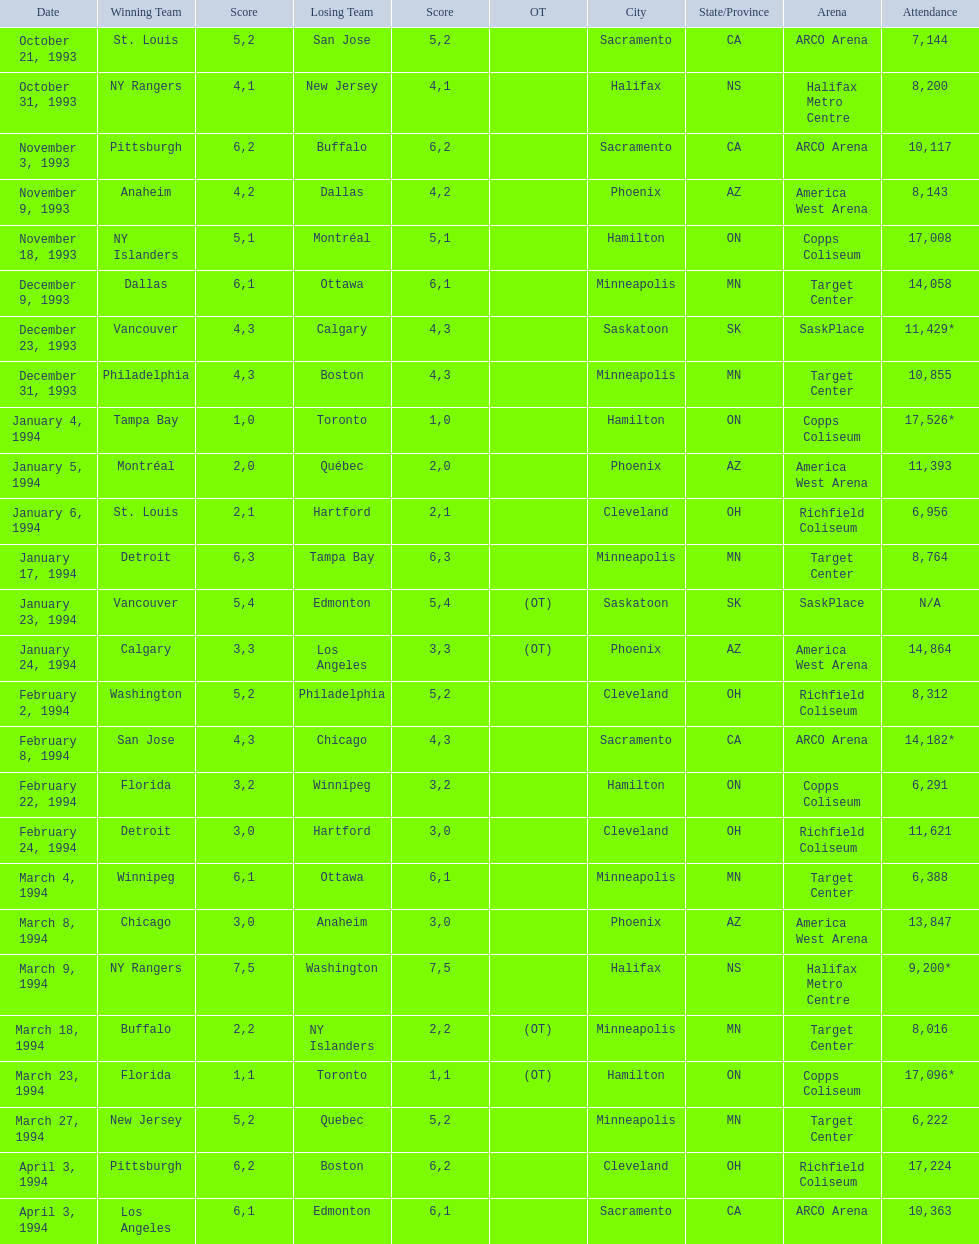When was the first time tampa bay emerged victorious in a neutral site game? January 4, 1994. 